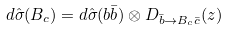<formula> <loc_0><loc_0><loc_500><loc_500>d \hat { \sigma } ( B _ { c } ) = d \hat { \sigma } ( b \bar { b } ) \otimes D _ { \bar { b } \rightarrow B _ { c } \bar { c } } ( z )</formula> 